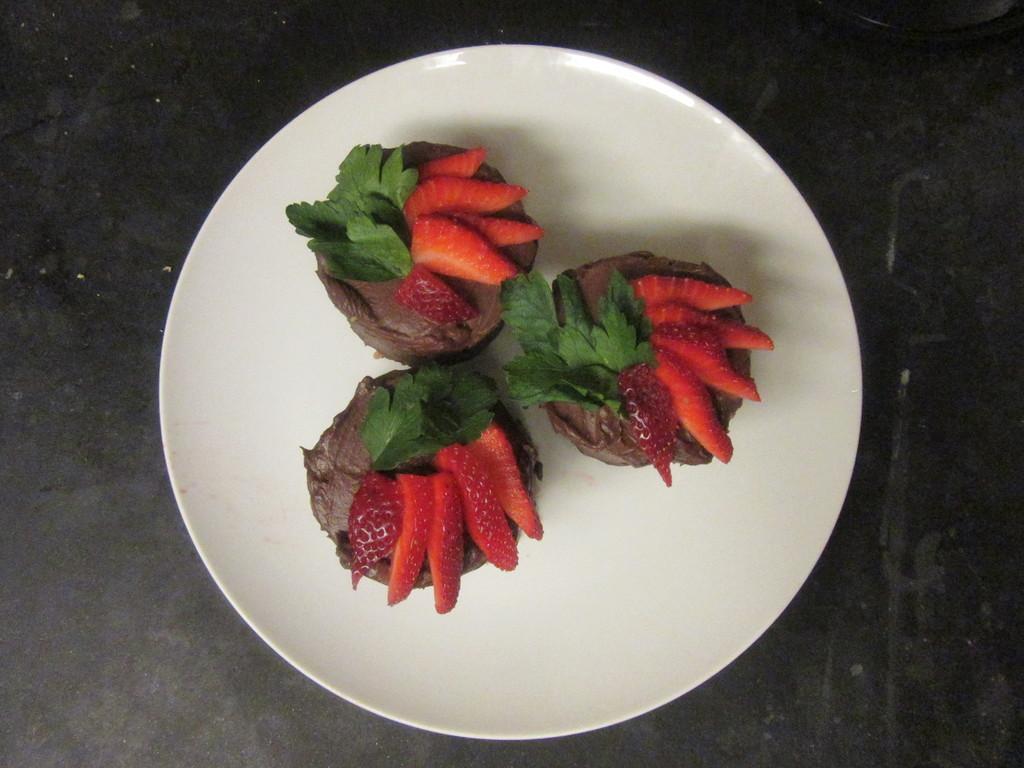Describe this image in one or two sentences. In this image in the center there is one plate, and in the plate there are some fruits and in the background there is a table. 